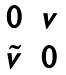<formula> <loc_0><loc_0><loc_500><loc_500>\begin{matrix} 0 & v \\ \tilde { v } & 0 \end{matrix}</formula> 